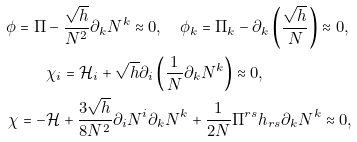Convert formula to latex. <formula><loc_0><loc_0><loc_500><loc_500>\phi = \Pi & - \frac { \sqrt { h } } { N ^ { 2 } } \partial _ { k } N ^ { k } \approx 0 , \quad \phi _ { k } = \Pi _ { k } - \partial _ { k } \left ( \frac { \sqrt { h } } { N } \right ) \approx 0 , \\ & \chi _ { i } = \mathcal { H } _ { i } + \sqrt { h } \partial _ { i } \left ( \frac { 1 } { N } \partial _ { k } N ^ { k } \right ) \approx 0 , \\ \chi = - & \mathcal { H } + \frac { 3 \sqrt { h } } { 8 N ^ { 2 } } \partial _ { i } N ^ { i } \partial _ { k } N ^ { k } + \frac { 1 } { 2 N } \Pi ^ { r s } h _ { r s } \partial _ { k } N ^ { k } \approx 0 ,</formula> 